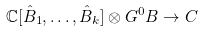Convert formula to latex. <formula><loc_0><loc_0><loc_500><loc_500>\mathbb { C } [ \hat { B } _ { 1 } , \dots , \hat { B } _ { k } ] \otimes G ^ { 0 } B \rightarrow C</formula> 